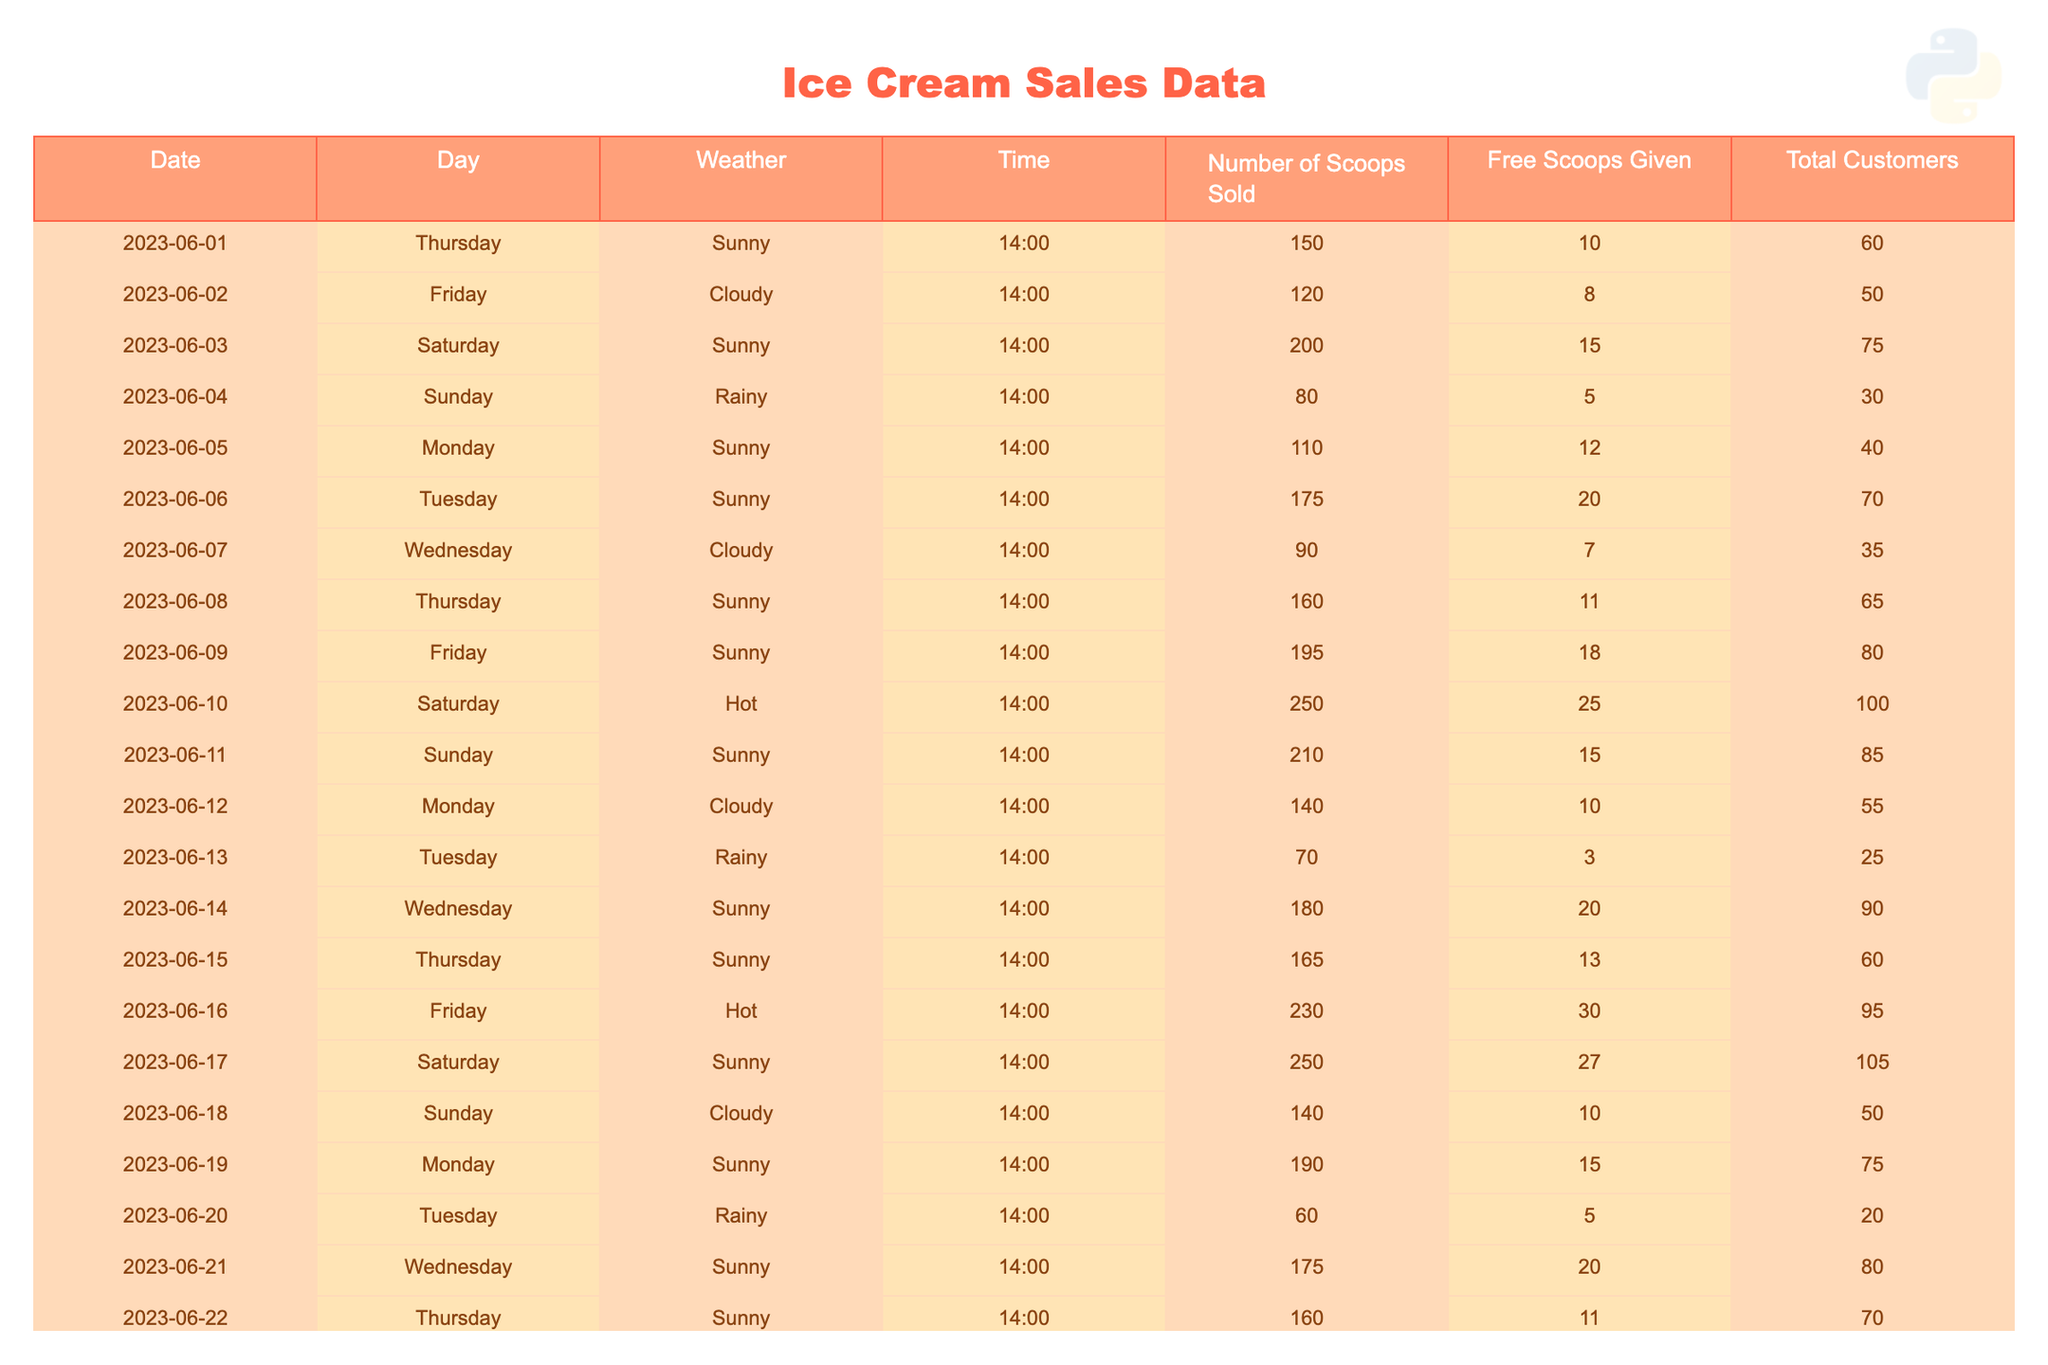What was the highest number of scoops sold on a single day? The highest number of scoops sold in a single day can be found by scanning the "Number of Scoops Sold" column for the maximum value. The maximum is 280 scoops sold on June 24.
Answer: 280 On how many days did we give out free scoops to customers? To determine the days with free scoops given, I sum the total instances where "Free Scoops Given" is greater than 0. There are 25 instances of free scoops being given.
Answer: 25 What was the average number of scoops sold on rainy days? I first filter the data to find all the entries on rainy days (June 4, June 13, June 20, June 27), which sold 80, 70, 60, and 80 scoops respectively. Adding these gives 290, and dividing by 4 days gives an average of 72.5.
Answer: 72.5 Was there more ice cream sold on sunny days compared to cloudy days? I compare the total scoops sold on sunny (sum is 1820) and cloudy days (sum is 460). Since 1820 is greater than 460, there was more sold on sunny days.
Answer: Yes What is the total number of customers for the entire month of June? I sum the values in the "Total Customers" column for all days in June. The totals add up to 1,730 customers for the month.
Answer: 1730 On which day was the second highest number of scoops sold, and how many were sold? I identify the top two days from the "Number of Scoops Sold" column: June 24 with 280 scoops and June 10 with 250 scoops, making June 10 the second highest with 250 scoops sold.
Answer: June 10, 250 How did the number of free scoops given compare on the hottest days versus other days? Hottest days (June 10, 16, 23): 25 + 30 + 26 = 81 free scoops. Other days gave 135. Since 81 is less than 135, fewer free scoops were given on the hottest days.
Answer: Fewer free scoops on hottest days What was the total number of scoops sold in the first week of June? I total the "Number of Scoops Sold" for June 1 through June 7, which yields 150 + 120 + 200 + 80 + 110 + 175 + 90 = 925 scoops sold in the first week.
Answer: 925 Did we serve more customers on weekends (Saturday and Sunday) than on weekdays? I calculate total customers for weekends (June 3, 4, 10, 11, 17, 18, 24, 25) which sum to 560. Weekdays total to 1,170, hence weekdays had more customers.
Answer: No 